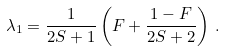<formula> <loc_0><loc_0><loc_500><loc_500>\lambda _ { 1 } = \frac { 1 } { 2 S + 1 } \left ( F + \frac { 1 - F } { 2 S + 2 } \right ) \, .</formula> 